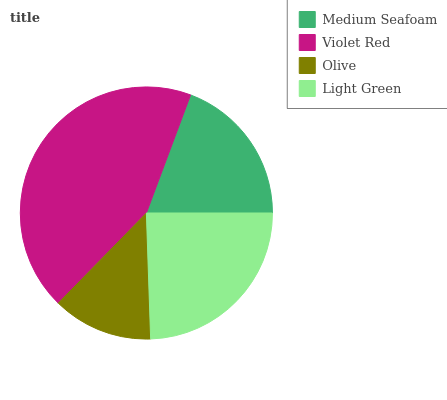Is Olive the minimum?
Answer yes or no. Yes. Is Violet Red the maximum?
Answer yes or no. Yes. Is Violet Red the minimum?
Answer yes or no. No. Is Olive the maximum?
Answer yes or no. No. Is Violet Red greater than Olive?
Answer yes or no. Yes. Is Olive less than Violet Red?
Answer yes or no. Yes. Is Olive greater than Violet Red?
Answer yes or no. No. Is Violet Red less than Olive?
Answer yes or no. No. Is Light Green the high median?
Answer yes or no. Yes. Is Medium Seafoam the low median?
Answer yes or no. Yes. Is Medium Seafoam the high median?
Answer yes or no. No. Is Olive the low median?
Answer yes or no. No. 